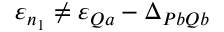<formula> <loc_0><loc_0><loc_500><loc_500>\varepsilon _ { n _ { 1 } } \neq \varepsilon _ { Q a } - \Delta _ { P b Q b }</formula> 